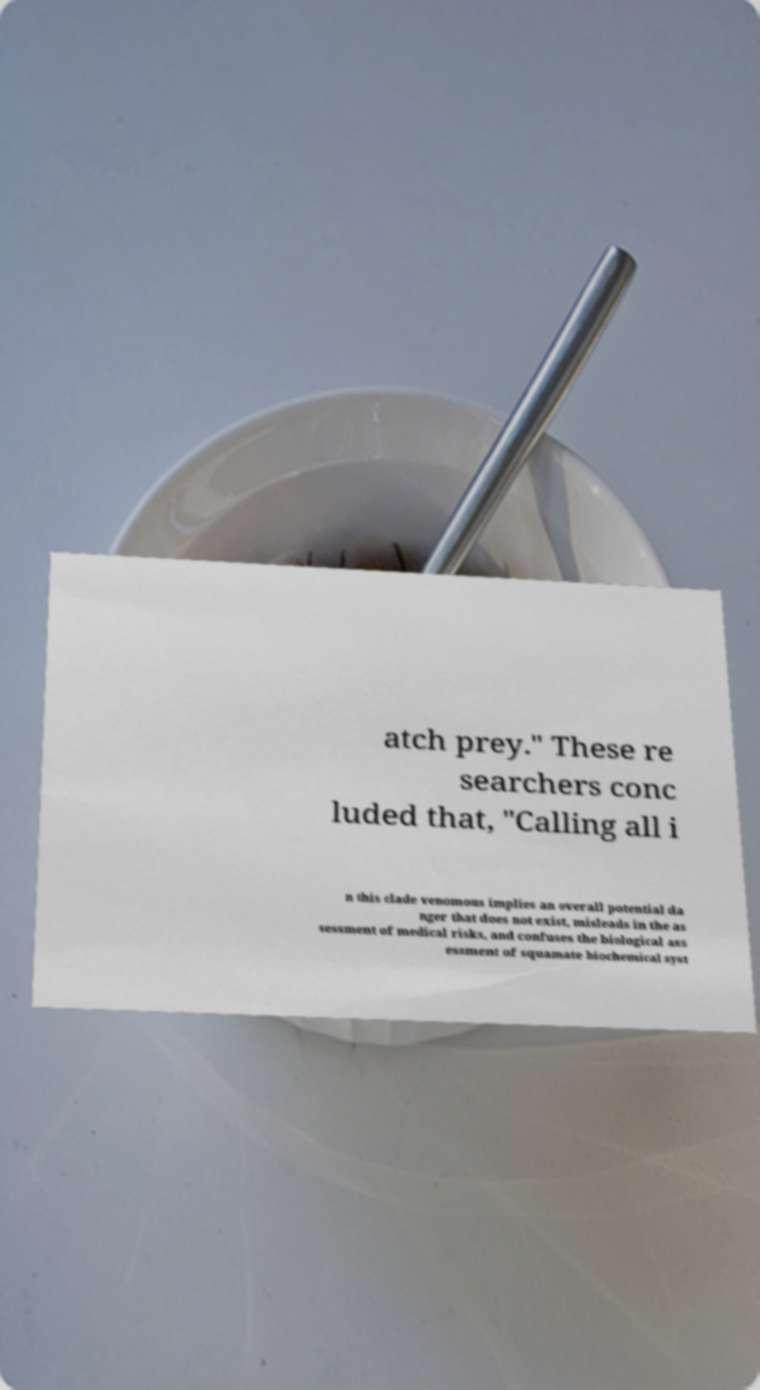Could you extract and type out the text from this image? atch prey." These re searchers conc luded that, "Calling all i n this clade venomous implies an overall potential da nger that does not exist, misleads in the as sessment of medical risks, and confuses the biological ass essment of squamate biochemical syst 